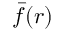Convert formula to latex. <formula><loc_0><loc_0><loc_500><loc_500>\bar { f } ( r )</formula> 